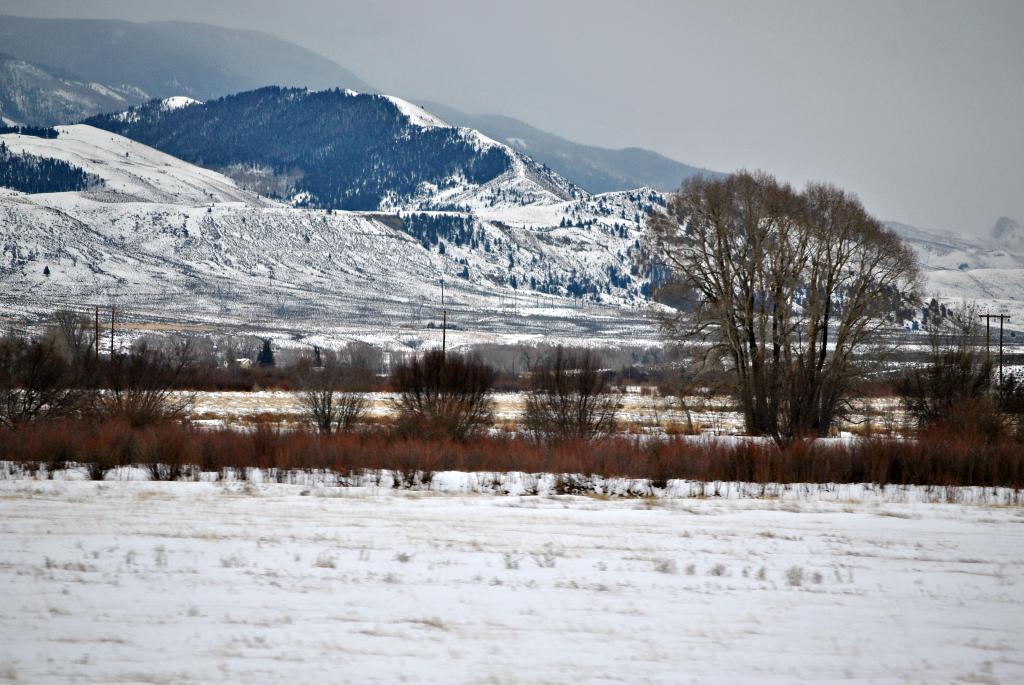Please provide a concise description of this image. In this image, there are a few hills, trees. We can see the ground covered with snow. We can see some plants, poles and the sky. 